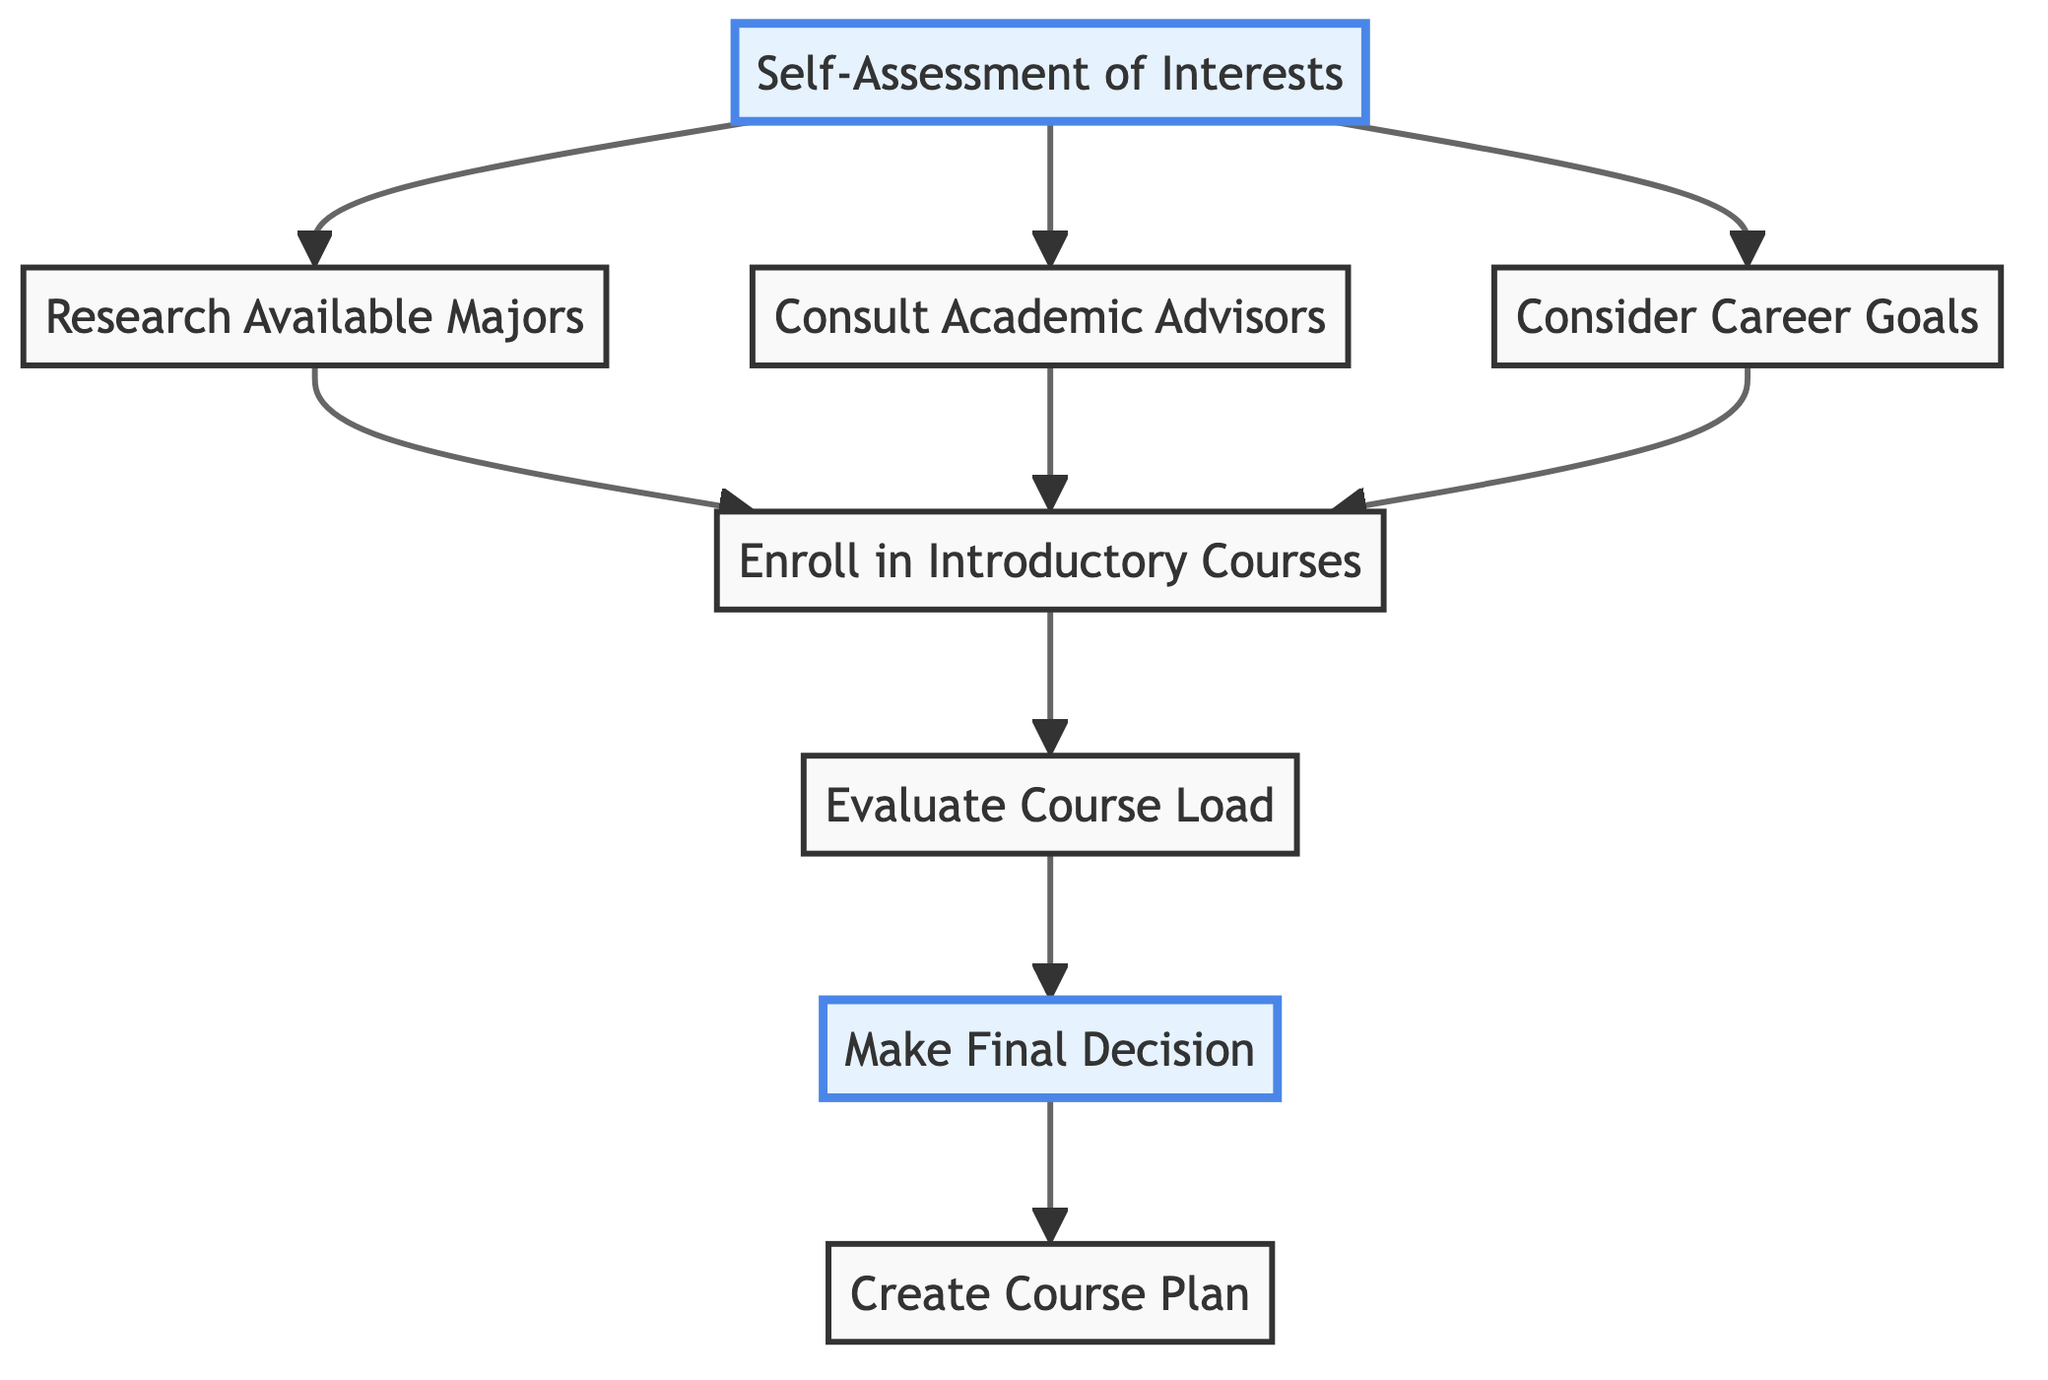What is the first step in the flowchart? The diagram indicates that the first action is "Self-Assessment of Interests," which is the starting point for the decision-making process.
Answer: Self-Assessment of Interests How many nodes are in the diagram? By counting all the unique processes in the flowchart, there are a total of 8 nodes, including both the starting and ending points.
Answer: 8 Which step comes after "Enroll in Introductory Courses"? The diagram shows that after "Enroll in Introductory Courses," the next step is "Evaluate Course Load," clearly indicating the progression of the flowchart.
Answer: Evaluate Course Load What decision is made at the final step of the flowchart? The last node mentions "Make Final Decision," signifying that this is the point where the chosen major is finalized based on the preceding assessments and evaluations.
Answer: Make Final Decision What connects "Research Available Majors" and "Enroll in Introductory Courses"? The flowchart specifies that "Research Available Majors" leads directly to "Enroll in Introductory Courses," indicating a direct dependency between the two steps in the process.
Answer: Enroll in Introductory Courses What major action is suggested after "Consider Career Goals"? Following "Consider Career Goals," the diagram directs towards "Enroll in Introductory Courses," which involves taking foundational classes related to the interested majors.
Answer: Enroll in Introductory Courses How many decision paths are considered from "Self-Assessment of Interests"? From "Self-Assessment of Interests," the path branches out to three different actions: "Research Available Majors," "Consult Academic Advisors," and "Consider Career Goals," showcasing various avenues to explore.
Answer: 3 What is the last action to complete after "Create Course Plan"? The flowchart does not specify any steps following "Create Course Plan," indicating that this is the final action to be undertaken regarding major and course pathway selection.
Answer: None 